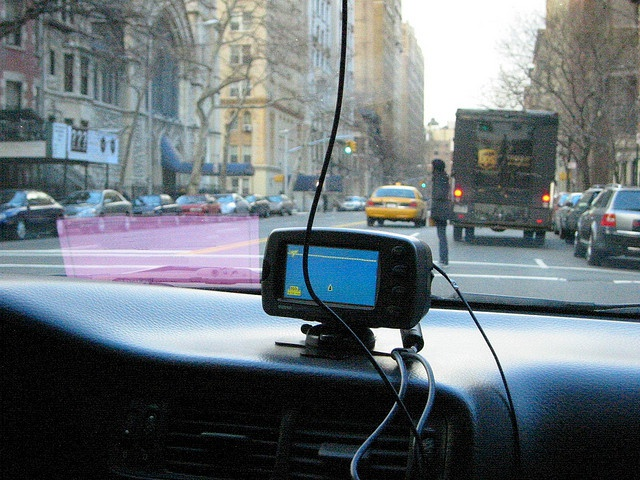Describe the objects in this image and their specific colors. I can see car in gray, darkgray, white, and black tones, truck in gray, black, and purple tones, tv in gray and teal tones, car in gray, darkgray, and black tones, and car in gray, black, blue, and darkblue tones in this image. 